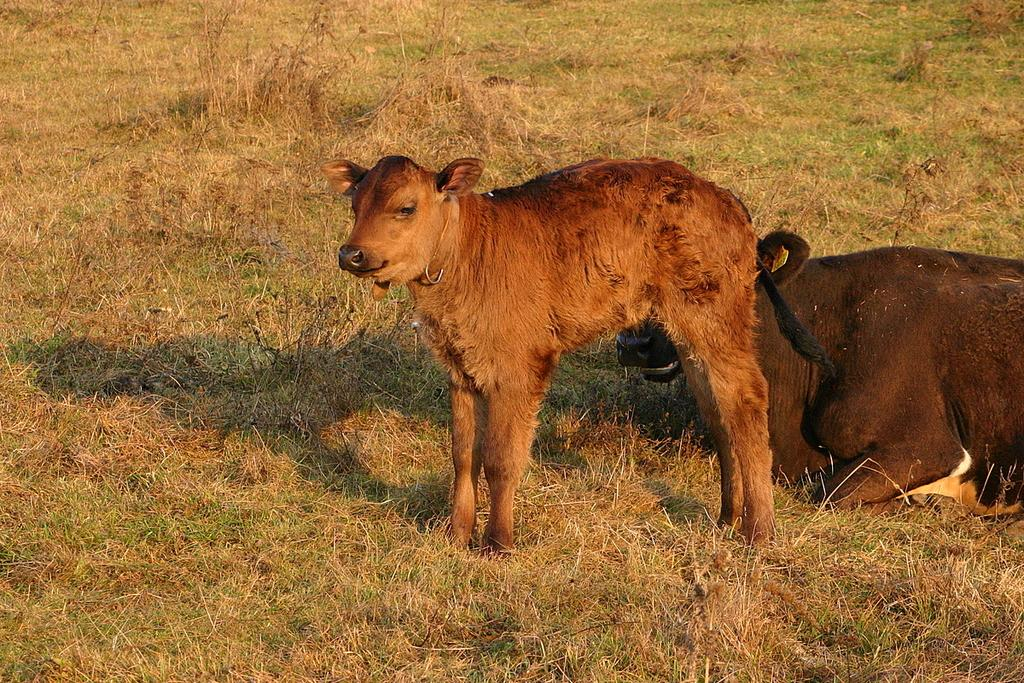What animal is located in the center of the image? There is a calf in the center of the image. What other animal can be seen on the right side of the image? There is a buffalo on the right side of the image. What type of vegetation is present in the image? Shrubs are present in the image. What is the ground covered with in the image? Grass is visible in the image. What type of comb is the calf using to groom the buffalo in the image? There is no comb present in the image, and the calf is not grooming the buffalo. 